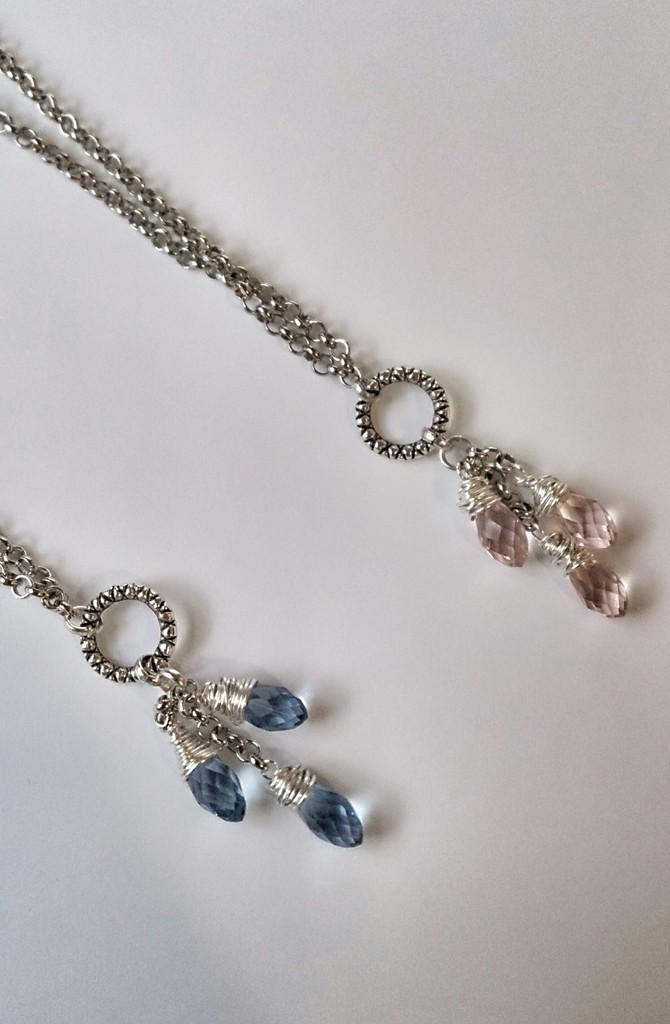What objects can be seen in the image? There are two chains in the image. What type of card is being used to fly the airplane in the image? There is no airplane or card present in the image; it only features two chains. 